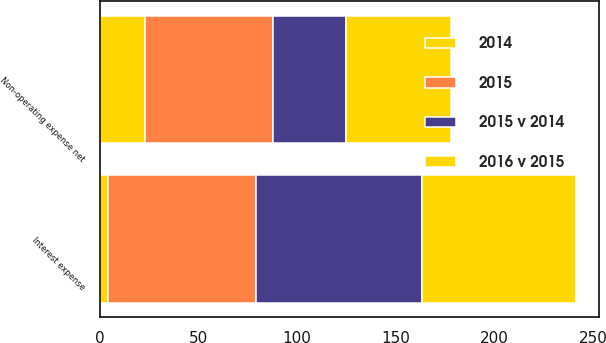Convert chart to OTSL. <chart><loc_0><loc_0><loc_500><loc_500><stacked_bar_chart><ecel><fcel>Interest expense<fcel>Non-operating expense net<nl><fcel>2015<fcel>75<fcel>65<nl><fcel>2016 v 2015<fcel>78<fcel>53<nl><fcel>2015 v 2014<fcel>84<fcel>37<nl><fcel>2014<fcel>4<fcel>23<nl></chart> 